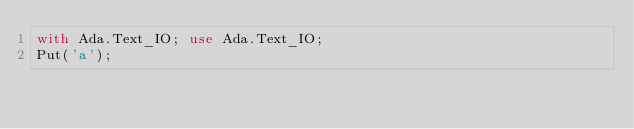<code> <loc_0><loc_0><loc_500><loc_500><_Ada_>with Ada.Text_IO; use Ada.Text_IO;
Put('a');
</code> 